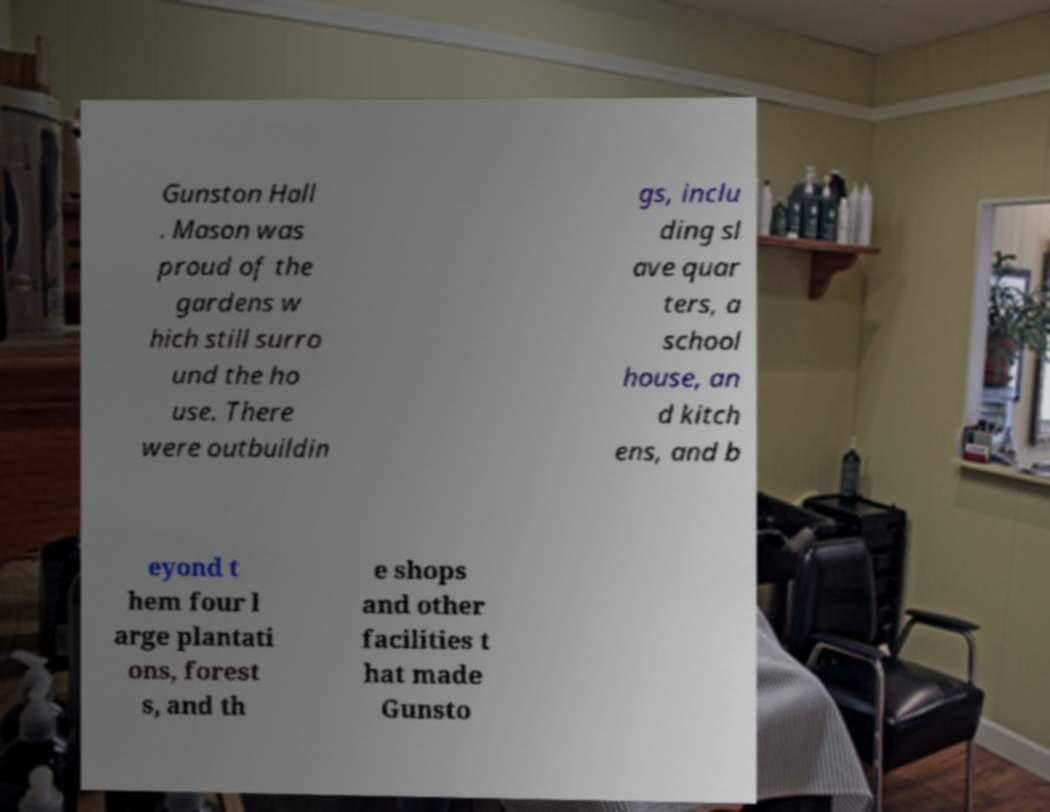Can you read and provide the text displayed in the image?This photo seems to have some interesting text. Can you extract and type it out for me? Gunston Hall . Mason was proud of the gardens w hich still surro und the ho use. There were outbuildin gs, inclu ding sl ave quar ters, a school house, an d kitch ens, and b eyond t hem four l arge plantati ons, forest s, and th e shops and other facilities t hat made Gunsto 